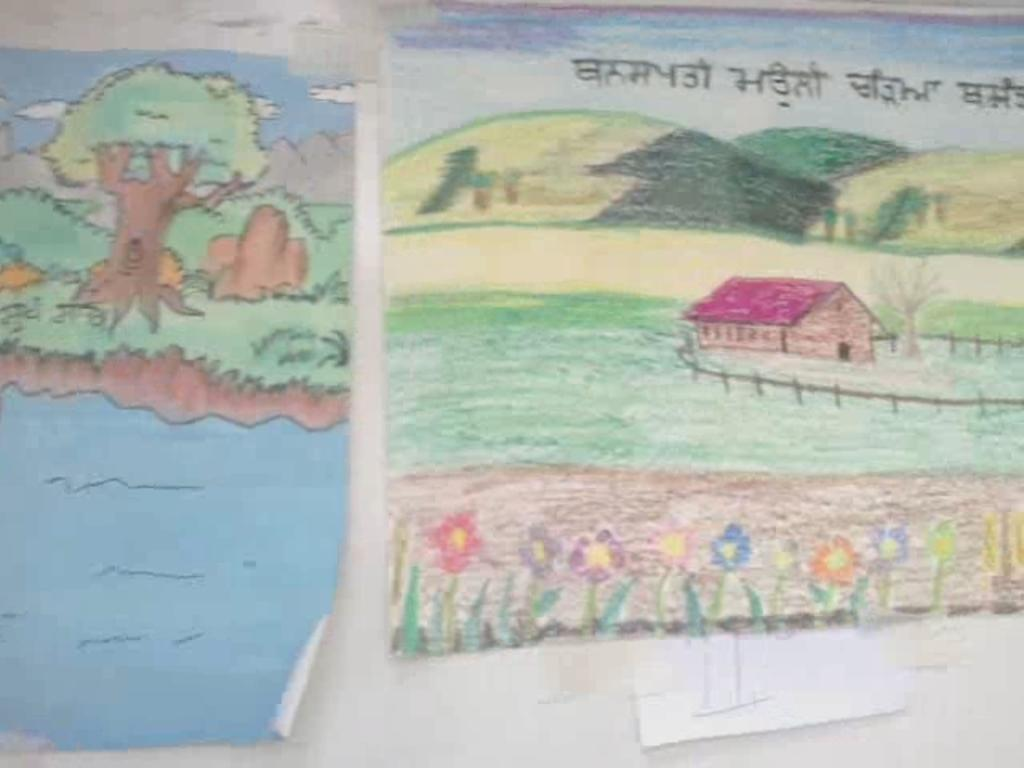What is depicted on the charts in the image? There are paintings on the charts in the image. Where are the paintings located? The paintings are on the wall. What additional information can be found on the charts? There is text at the top of one chart in the image. What type of cabbage is being sold at the store in the image? There is no store or cabbage present in the image; it features paintings on charts with text on one of them. 